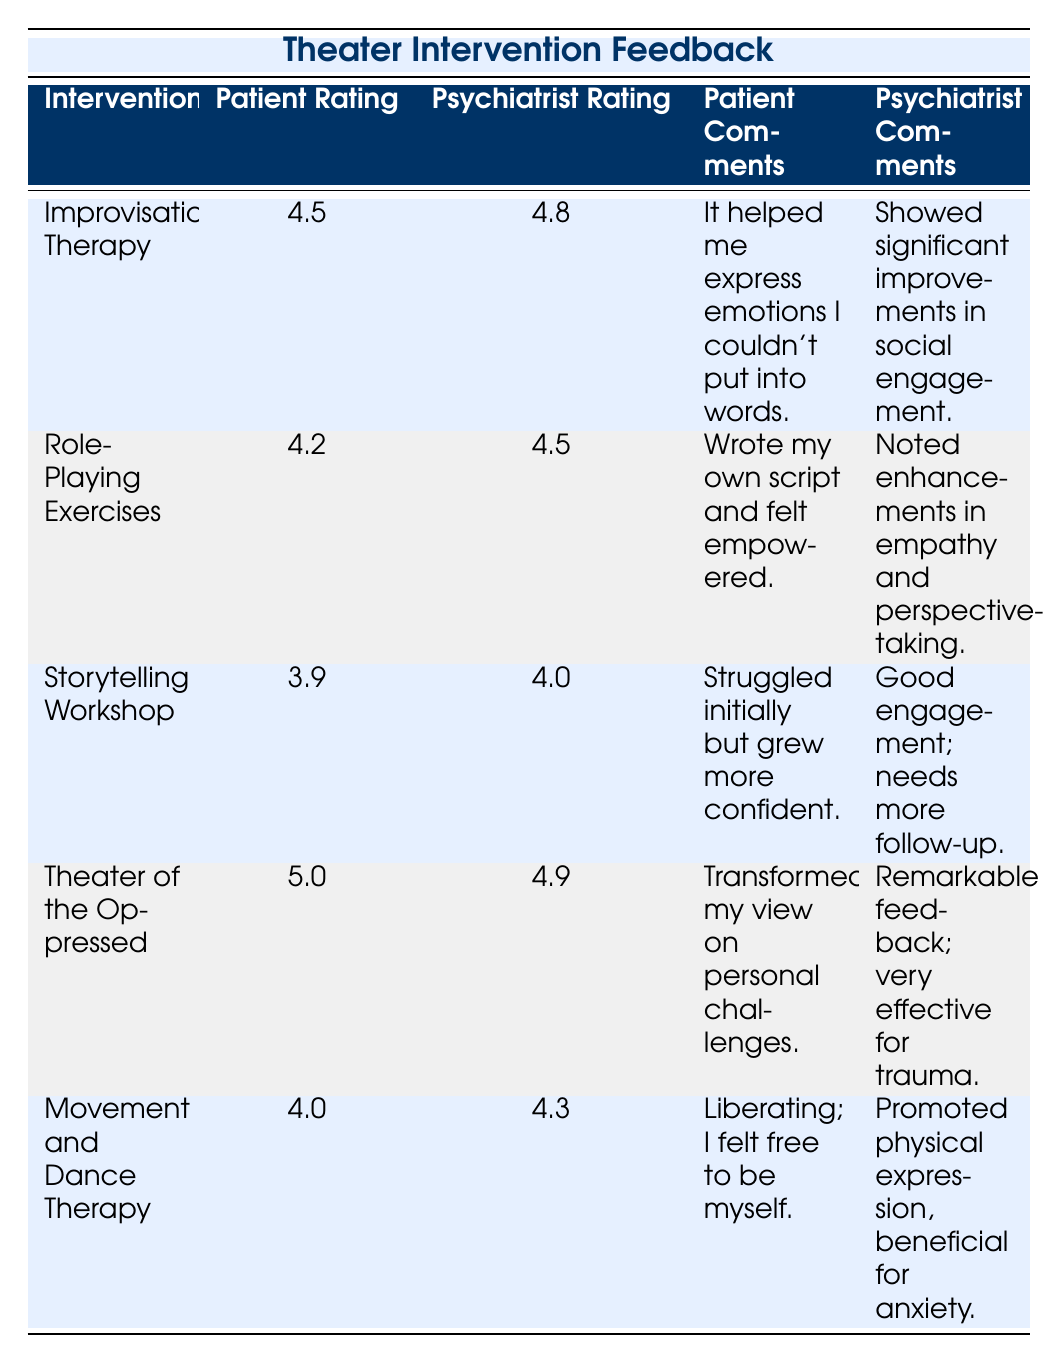What is the patient rating for the Theater of the Oppressed? According to the table, the patient rating for the Theater of the Oppressed is explicitly listed as 5.0.
Answer: 5.0 What are the psychiatrist comments for Movement and Dance Therapy? The table specifies that the psychiatrist comments for Movement and Dance Therapy are "Promoted physical expression, beneficial for anxiety."
Answer: Promoted physical expression, beneficial for anxiety Which intervention received the highest patient rating? The table shows that the intervention with the highest patient rating is "Theater of the Oppressed," with a rating of 5.0.
Answer: Theater of the Oppressed What is the average patient rating for all interventions? To calculate the average, sum the patient ratings: (4.5 + 4.2 + 3.9 + 5.0 + 4.0) = 21.6. There are 5 interventions, so the average is 21.6 / 5 = 4.32.
Answer: 4.32 Did any intervention receive a psychiatrist rating of 5.0 or higher? The table shows that no psychiatrist rating listed is 5.0 or higher, as the highest rating is 4.9 for the Theater of the Oppressed.
Answer: No What is the difference between the highest and lowest patient rating? The highest patient rating is 5.0 (Theater of the Oppressed) and the lowest is 3.9 (Storytelling Workshop). The difference is 5.0 - 3.9 = 1.1.
Answer: 1.1 Which intervention has the lowest psychiatrist rating? Reviewing the psychiatrist ratings in the table, "Storytelling Workshop" has the lowest rating at 4.0.
Answer: Storytelling Workshop Is there an intervention where patient and psychiatrist ratings are exactly the same? The table confirms that no intervention has identical patient and psychiatrist ratings; they all differ.
Answer: No How did patients describe their experience with Improvisational Therapy? According to the table, patients described their experience with Improvisational Therapy by saying, "It helped me express emotions I couldn't put into words."
Answer: It helped me express emotions I couldn't put into words 